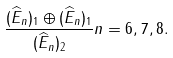Convert formula to latex. <formula><loc_0><loc_0><loc_500><loc_500>\frac { ( \widehat { E } _ { n } ) _ { 1 } \oplus ( \widehat { E } _ { n } ) _ { 1 } } { ( \widehat { E } _ { n } ) _ { 2 } } n = 6 , 7 , 8 .</formula> 